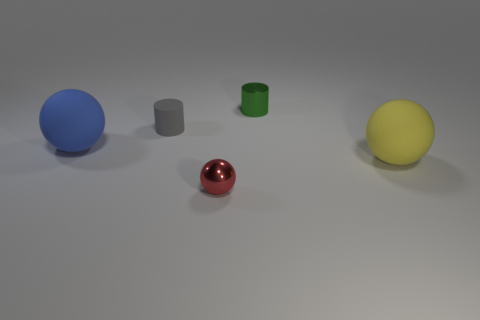The yellow sphere has what size?
Your answer should be very brief. Large. Are there more green objects on the right side of the big yellow matte object than large yellow rubber things that are behind the small matte cylinder?
Provide a succinct answer. No. Are there any yellow objects behind the tiny green metallic cylinder?
Provide a short and direct response. No. Are there any brown cylinders that have the same size as the green cylinder?
Ensure brevity in your answer.  No. There is another small thing that is made of the same material as the small green object; what is its color?
Provide a short and direct response. Red. What is the material of the big yellow ball?
Your answer should be compact. Rubber. The small gray thing is what shape?
Offer a terse response. Cylinder. How many rubber spheres are the same color as the rubber cylinder?
Give a very brief answer. 0. There is a tiny object that is right of the tiny shiny object in front of the large matte object that is on the right side of the tiny metal cylinder; what is it made of?
Make the answer very short. Metal. How many cyan things are either big matte balls or small cylinders?
Your answer should be compact. 0. 